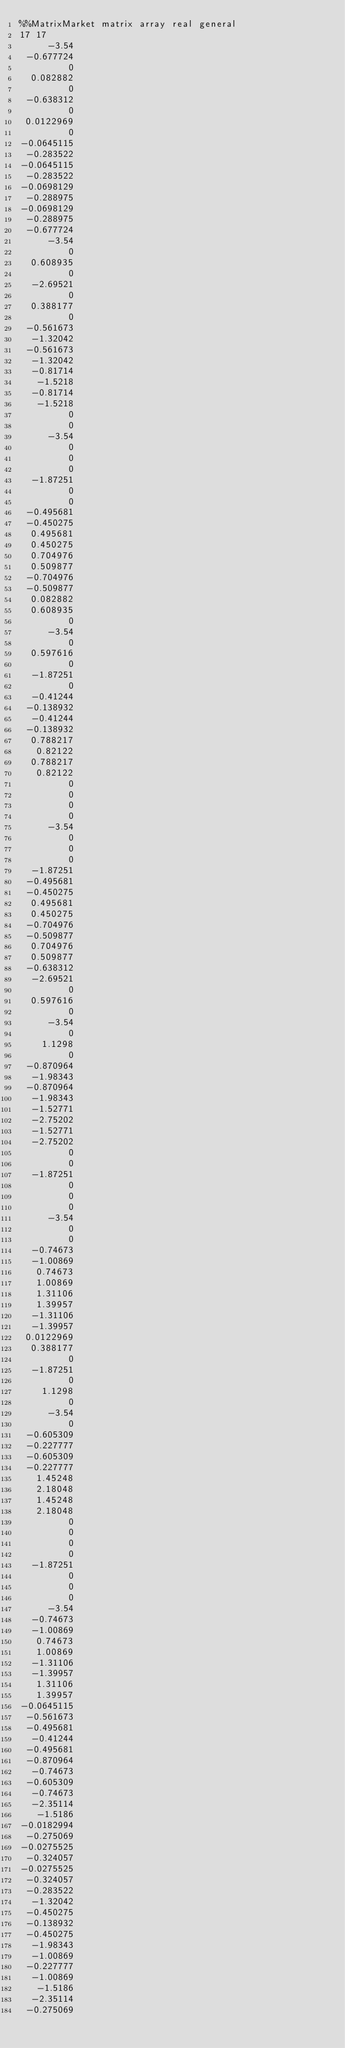Convert code to text. <code><loc_0><loc_0><loc_500><loc_500><_ObjectiveC_>%%MatrixMarket matrix array real general
17 17
     -3.54
 -0.677724
         0
  0.082882
         0
 -0.638312
         0
 0.0122969
         0
-0.0645115
 -0.283522
-0.0645115
 -0.283522
-0.0698129
 -0.288975
-0.0698129
 -0.288975
 -0.677724
     -3.54
         0
  0.608935
         0
  -2.69521
         0
  0.388177
         0
 -0.561673
  -1.32042
 -0.561673
  -1.32042
  -0.81714
   -1.5218
  -0.81714
   -1.5218
         0
         0
     -3.54
         0
         0
         0
  -1.87251
         0
         0
 -0.495681
 -0.450275
  0.495681
  0.450275
  0.704976
  0.509877
 -0.704976
 -0.509877
  0.082882
  0.608935
         0
     -3.54
         0
  0.597616
         0
  -1.87251
         0
  -0.41244
 -0.138932
  -0.41244
 -0.138932
  0.788217
   0.82122
  0.788217
   0.82122
         0
         0
         0
         0
     -3.54
         0
         0
         0
  -1.87251
 -0.495681
 -0.450275
  0.495681
  0.450275
 -0.704976
 -0.509877
  0.704976
  0.509877
 -0.638312
  -2.69521
         0
  0.597616
         0
     -3.54
         0
    1.1298
         0
 -0.870964
  -1.98343
 -0.870964
  -1.98343
  -1.52771
  -2.75202
  -1.52771
  -2.75202
         0
         0
  -1.87251
         0
         0
         0
     -3.54
         0
         0
  -0.74673
  -1.00869
   0.74673
   1.00869
   1.31106
   1.39957
  -1.31106
  -1.39957
 0.0122969
  0.388177
         0
  -1.87251
         0
    1.1298
         0
     -3.54
         0
 -0.605309
 -0.227777
 -0.605309
 -0.227777
   1.45248
   2.18048
   1.45248
   2.18048
         0
         0
         0
         0
  -1.87251
         0
         0
         0
     -3.54
  -0.74673
  -1.00869
   0.74673
   1.00869
  -1.31106
  -1.39957
   1.31106
   1.39957
-0.0645115
 -0.561673
 -0.495681
  -0.41244
 -0.495681
 -0.870964
  -0.74673
 -0.605309
  -0.74673
  -2.35114
   -1.5186
-0.0182994
 -0.275069
-0.0275525
 -0.324057
-0.0275525
 -0.324057
 -0.283522
  -1.32042
 -0.450275
 -0.138932
 -0.450275
  -1.98343
  -1.00869
 -0.227777
  -1.00869
   -1.5186
  -2.35114
 -0.275069</code> 